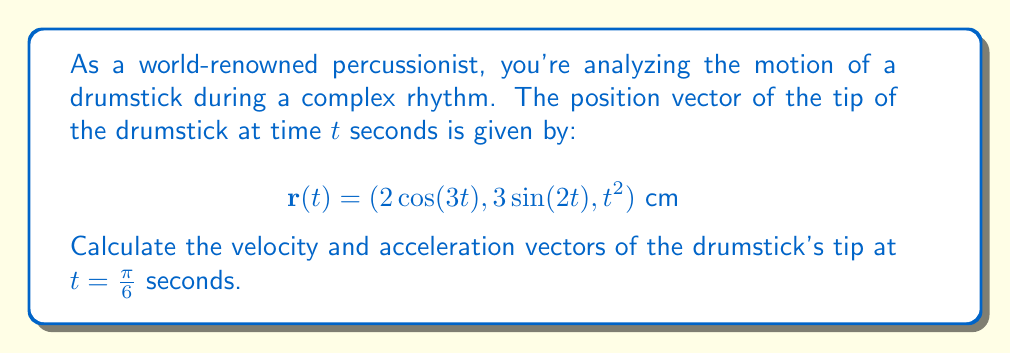Show me your answer to this math problem. To solve this problem, we need to follow these steps:

1) First, let's calculate the velocity vector. The velocity is the first derivative of the position vector with respect to time:

   $$\mathbf{v}(t) = \frac{d\mathbf{r}}{dt} = (-6\sin(3t), 6\cos(2t), 2t) \text{ cm/s}$$

2) Now, let's calculate the acceleration vector. The acceleration is the second derivative of the position vector with respect to time, or the first derivative of the velocity vector:

   $$\mathbf{a}(t) = \frac{d\mathbf{v}}{dt} = (-18\cos(3t), -12\sin(2t), 2) \text{ cm/s}^2$$

3) Now we need to evaluate these vectors at $t = \frac{\pi}{6}$:

   For velocity:
   $$\mathbf{v}(\frac{\pi}{6}) = (-6\sin(\frac{\pi}{2}), 6\cos(\frac{\pi}{3}), 2\cdot\frac{\pi}{6})$$
   $$= (-6, 3, \frac{\pi}{3}) \text{ cm/s}$$

   For acceleration:
   $$\mathbf{a}(\frac{\pi}{6}) = (-18\cos(\frac{\pi}{2}), -12\sin(\frac{\pi}{3}), 2)$$
   $$= (0, -6\sqrt{3}, 2) \text{ cm/s}^2$$

Therefore, at $t = \frac{\pi}{6}$ seconds, the velocity and acceleration vectors of the drumstick's tip are as calculated above.
Answer: At $t = \frac{\pi}{6}$ seconds:
Velocity: $\mathbf{v}(\frac{\pi}{6}) = (-6, 3, \frac{\pi}{3}) \text{ cm/s}$
Acceleration: $\mathbf{a}(\frac{\pi}{6}) = (0, -6\sqrt{3}, 2) \text{ cm/s}^2$ 